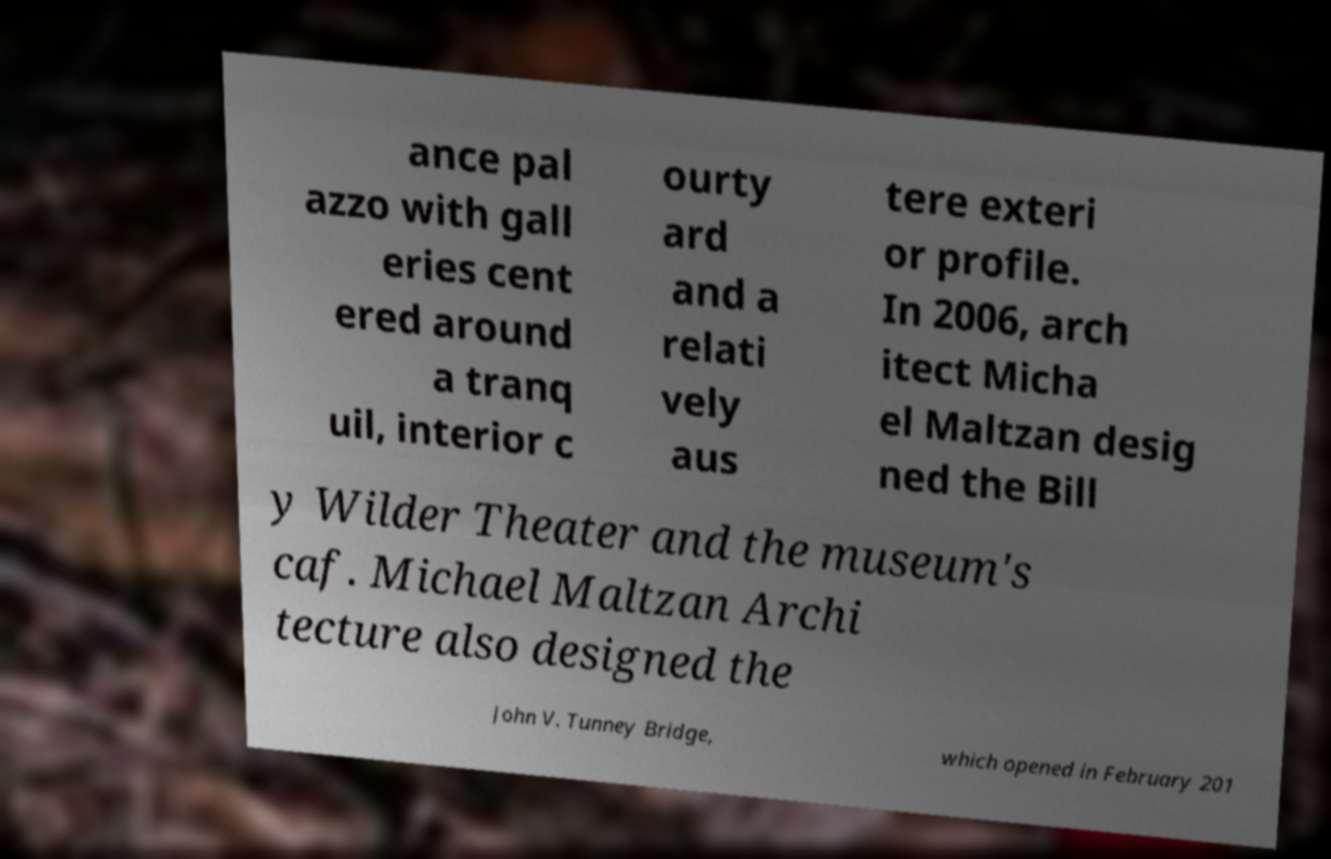What messages or text are displayed in this image? I need them in a readable, typed format. ance pal azzo with gall eries cent ered around a tranq uil, interior c ourty ard and a relati vely aus tere exteri or profile. In 2006, arch itect Micha el Maltzan desig ned the Bill y Wilder Theater and the museum's caf. Michael Maltzan Archi tecture also designed the John V. Tunney Bridge, which opened in February 201 